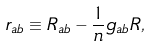<formula> <loc_0><loc_0><loc_500><loc_500>r _ { a b } \equiv R _ { a b } - \frac { 1 } { n } g _ { a b } R ,</formula> 